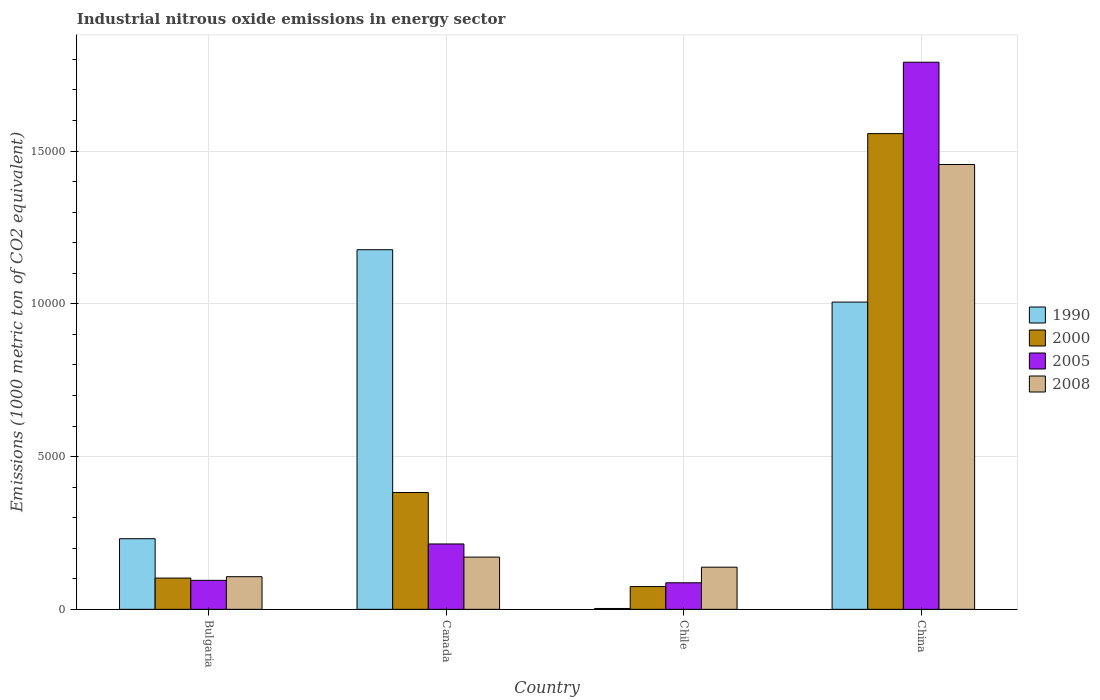Are the number of bars per tick equal to the number of legend labels?
Your answer should be compact. Yes. How many bars are there on the 4th tick from the right?
Offer a terse response. 4. What is the label of the 2nd group of bars from the left?
Provide a short and direct response. Canada. What is the amount of industrial nitrous oxide emitted in 2005 in Canada?
Make the answer very short. 2139.7. Across all countries, what is the maximum amount of industrial nitrous oxide emitted in 2008?
Offer a terse response. 1.46e+04. Across all countries, what is the minimum amount of industrial nitrous oxide emitted in 2008?
Offer a terse response. 1068. What is the total amount of industrial nitrous oxide emitted in 2000 in the graph?
Provide a succinct answer. 2.12e+04. What is the difference between the amount of industrial nitrous oxide emitted in 1990 in Bulgaria and that in Canada?
Your answer should be very brief. -9458.8. What is the difference between the amount of industrial nitrous oxide emitted in 2008 in China and the amount of industrial nitrous oxide emitted in 2000 in Bulgaria?
Provide a short and direct response. 1.35e+04. What is the average amount of industrial nitrous oxide emitted in 2005 per country?
Keep it short and to the point. 5465.88. What is the difference between the amount of industrial nitrous oxide emitted of/in 2008 and amount of industrial nitrous oxide emitted of/in 2005 in Bulgaria?
Ensure brevity in your answer.  119.4. What is the ratio of the amount of industrial nitrous oxide emitted in 2005 in Bulgaria to that in China?
Provide a succinct answer. 0.05. Is the amount of industrial nitrous oxide emitted in 2008 in Bulgaria less than that in China?
Offer a very short reply. Yes. Is the difference between the amount of industrial nitrous oxide emitted in 2008 in Bulgaria and Canada greater than the difference between the amount of industrial nitrous oxide emitted in 2005 in Bulgaria and Canada?
Offer a very short reply. Yes. What is the difference between the highest and the second highest amount of industrial nitrous oxide emitted in 1990?
Ensure brevity in your answer.  -1713.9. What is the difference between the highest and the lowest amount of industrial nitrous oxide emitted in 2000?
Provide a short and direct response. 1.48e+04. In how many countries, is the amount of industrial nitrous oxide emitted in 1990 greater than the average amount of industrial nitrous oxide emitted in 1990 taken over all countries?
Offer a terse response. 2. Is it the case that in every country, the sum of the amount of industrial nitrous oxide emitted in 1990 and amount of industrial nitrous oxide emitted in 2005 is greater than the sum of amount of industrial nitrous oxide emitted in 2000 and amount of industrial nitrous oxide emitted in 2008?
Provide a short and direct response. No. What does the 3rd bar from the left in Bulgaria represents?
Your response must be concise. 2005. What does the 3rd bar from the right in Chile represents?
Keep it short and to the point. 2000. Is it the case that in every country, the sum of the amount of industrial nitrous oxide emitted in 2008 and amount of industrial nitrous oxide emitted in 1990 is greater than the amount of industrial nitrous oxide emitted in 2005?
Ensure brevity in your answer.  Yes. How many bars are there?
Keep it short and to the point. 16. Are all the bars in the graph horizontal?
Ensure brevity in your answer.  No. How many countries are there in the graph?
Your response must be concise. 4. Are the values on the major ticks of Y-axis written in scientific E-notation?
Your answer should be very brief. No. Does the graph contain grids?
Keep it short and to the point. Yes. How many legend labels are there?
Offer a very short reply. 4. How are the legend labels stacked?
Ensure brevity in your answer.  Vertical. What is the title of the graph?
Ensure brevity in your answer.  Industrial nitrous oxide emissions in energy sector. Does "2009" appear as one of the legend labels in the graph?
Your answer should be compact. No. What is the label or title of the Y-axis?
Give a very brief answer. Emissions (1000 metric ton of CO2 equivalent). What is the Emissions (1000 metric ton of CO2 equivalent) in 1990 in Bulgaria?
Offer a very short reply. 2311.2. What is the Emissions (1000 metric ton of CO2 equivalent) in 2000 in Bulgaria?
Your answer should be very brief. 1023. What is the Emissions (1000 metric ton of CO2 equivalent) in 2005 in Bulgaria?
Your answer should be very brief. 948.6. What is the Emissions (1000 metric ton of CO2 equivalent) in 2008 in Bulgaria?
Your answer should be compact. 1068. What is the Emissions (1000 metric ton of CO2 equivalent) in 1990 in Canada?
Your answer should be compact. 1.18e+04. What is the Emissions (1000 metric ton of CO2 equivalent) in 2000 in Canada?
Make the answer very short. 3823.3. What is the Emissions (1000 metric ton of CO2 equivalent) in 2005 in Canada?
Make the answer very short. 2139.7. What is the Emissions (1000 metric ton of CO2 equivalent) in 2008 in Canada?
Keep it short and to the point. 1709.6. What is the Emissions (1000 metric ton of CO2 equivalent) in 1990 in Chile?
Ensure brevity in your answer.  27.9. What is the Emissions (1000 metric ton of CO2 equivalent) of 2000 in Chile?
Ensure brevity in your answer.  744.9. What is the Emissions (1000 metric ton of CO2 equivalent) of 2005 in Chile?
Give a very brief answer. 868.8. What is the Emissions (1000 metric ton of CO2 equivalent) of 2008 in Chile?
Offer a very short reply. 1379.7. What is the Emissions (1000 metric ton of CO2 equivalent) of 1990 in China?
Ensure brevity in your answer.  1.01e+04. What is the Emissions (1000 metric ton of CO2 equivalent) in 2000 in China?
Make the answer very short. 1.56e+04. What is the Emissions (1000 metric ton of CO2 equivalent) in 2005 in China?
Offer a terse response. 1.79e+04. What is the Emissions (1000 metric ton of CO2 equivalent) of 2008 in China?
Your answer should be very brief. 1.46e+04. Across all countries, what is the maximum Emissions (1000 metric ton of CO2 equivalent) in 1990?
Your answer should be compact. 1.18e+04. Across all countries, what is the maximum Emissions (1000 metric ton of CO2 equivalent) in 2000?
Your response must be concise. 1.56e+04. Across all countries, what is the maximum Emissions (1000 metric ton of CO2 equivalent) in 2005?
Provide a succinct answer. 1.79e+04. Across all countries, what is the maximum Emissions (1000 metric ton of CO2 equivalent) in 2008?
Give a very brief answer. 1.46e+04. Across all countries, what is the minimum Emissions (1000 metric ton of CO2 equivalent) of 1990?
Offer a terse response. 27.9. Across all countries, what is the minimum Emissions (1000 metric ton of CO2 equivalent) of 2000?
Your answer should be very brief. 744.9. Across all countries, what is the minimum Emissions (1000 metric ton of CO2 equivalent) in 2005?
Offer a very short reply. 868.8. Across all countries, what is the minimum Emissions (1000 metric ton of CO2 equivalent) of 2008?
Provide a succinct answer. 1068. What is the total Emissions (1000 metric ton of CO2 equivalent) of 1990 in the graph?
Your answer should be very brief. 2.42e+04. What is the total Emissions (1000 metric ton of CO2 equivalent) of 2000 in the graph?
Keep it short and to the point. 2.12e+04. What is the total Emissions (1000 metric ton of CO2 equivalent) of 2005 in the graph?
Keep it short and to the point. 2.19e+04. What is the total Emissions (1000 metric ton of CO2 equivalent) of 2008 in the graph?
Provide a short and direct response. 1.87e+04. What is the difference between the Emissions (1000 metric ton of CO2 equivalent) of 1990 in Bulgaria and that in Canada?
Provide a succinct answer. -9458.8. What is the difference between the Emissions (1000 metric ton of CO2 equivalent) in 2000 in Bulgaria and that in Canada?
Provide a succinct answer. -2800.3. What is the difference between the Emissions (1000 metric ton of CO2 equivalent) in 2005 in Bulgaria and that in Canada?
Provide a succinct answer. -1191.1. What is the difference between the Emissions (1000 metric ton of CO2 equivalent) in 2008 in Bulgaria and that in Canada?
Your response must be concise. -641.6. What is the difference between the Emissions (1000 metric ton of CO2 equivalent) in 1990 in Bulgaria and that in Chile?
Give a very brief answer. 2283.3. What is the difference between the Emissions (1000 metric ton of CO2 equivalent) of 2000 in Bulgaria and that in Chile?
Ensure brevity in your answer.  278.1. What is the difference between the Emissions (1000 metric ton of CO2 equivalent) of 2005 in Bulgaria and that in Chile?
Your response must be concise. 79.8. What is the difference between the Emissions (1000 metric ton of CO2 equivalent) in 2008 in Bulgaria and that in Chile?
Offer a very short reply. -311.7. What is the difference between the Emissions (1000 metric ton of CO2 equivalent) of 1990 in Bulgaria and that in China?
Give a very brief answer. -7744.9. What is the difference between the Emissions (1000 metric ton of CO2 equivalent) in 2000 in Bulgaria and that in China?
Provide a short and direct response. -1.45e+04. What is the difference between the Emissions (1000 metric ton of CO2 equivalent) in 2005 in Bulgaria and that in China?
Keep it short and to the point. -1.70e+04. What is the difference between the Emissions (1000 metric ton of CO2 equivalent) in 2008 in Bulgaria and that in China?
Your response must be concise. -1.35e+04. What is the difference between the Emissions (1000 metric ton of CO2 equivalent) in 1990 in Canada and that in Chile?
Your response must be concise. 1.17e+04. What is the difference between the Emissions (1000 metric ton of CO2 equivalent) of 2000 in Canada and that in Chile?
Offer a terse response. 3078.4. What is the difference between the Emissions (1000 metric ton of CO2 equivalent) of 2005 in Canada and that in Chile?
Offer a terse response. 1270.9. What is the difference between the Emissions (1000 metric ton of CO2 equivalent) of 2008 in Canada and that in Chile?
Your answer should be compact. 329.9. What is the difference between the Emissions (1000 metric ton of CO2 equivalent) in 1990 in Canada and that in China?
Offer a terse response. 1713.9. What is the difference between the Emissions (1000 metric ton of CO2 equivalent) in 2000 in Canada and that in China?
Your answer should be very brief. -1.17e+04. What is the difference between the Emissions (1000 metric ton of CO2 equivalent) in 2005 in Canada and that in China?
Keep it short and to the point. -1.58e+04. What is the difference between the Emissions (1000 metric ton of CO2 equivalent) in 2008 in Canada and that in China?
Your response must be concise. -1.28e+04. What is the difference between the Emissions (1000 metric ton of CO2 equivalent) in 1990 in Chile and that in China?
Offer a very short reply. -1.00e+04. What is the difference between the Emissions (1000 metric ton of CO2 equivalent) of 2000 in Chile and that in China?
Your answer should be compact. -1.48e+04. What is the difference between the Emissions (1000 metric ton of CO2 equivalent) of 2005 in Chile and that in China?
Give a very brief answer. -1.70e+04. What is the difference between the Emissions (1000 metric ton of CO2 equivalent) in 2008 in Chile and that in China?
Give a very brief answer. -1.32e+04. What is the difference between the Emissions (1000 metric ton of CO2 equivalent) in 1990 in Bulgaria and the Emissions (1000 metric ton of CO2 equivalent) in 2000 in Canada?
Offer a terse response. -1512.1. What is the difference between the Emissions (1000 metric ton of CO2 equivalent) in 1990 in Bulgaria and the Emissions (1000 metric ton of CO2 equivalent) in 2005 in Canada?
Provide a succinct answer. 171.5. What is the difference between the Emissions (1000 metric ton of CO2 equivalent) in 1990 in Bulgaria and the Emissions (1000 metric ton of CO2 equivalent) in 2008 in Canada?
Offer a very short reply. 601.6. What is the difference between the Emissions (1000 metric ton of CO2 equivalent) of 2000 in Bulgaria and the Emissions (1000 metric ton of CO2 equivalent) of 2005 in Canada?
Give a very brief answer. -1116.7. What is the difference between the Emissions (1000 metric ton of CO2 equivalent) in 2000 in Bulgaria and the Emissions (1000 metric ton of CO2 equivalent) in 2008 in Canada?
Give a very brief answer. -686.6. What is the difference between the Emissions (1000 metric ton of CO2 equivalent) of 2005 in Bulgaria and the Emissions (1000 metric ton of CO2 equivalent) of 2008 in Canada?
Provide a short and direct response. -761. What is the difference between the Emissions (1000 metric ton of CO2 equivalent) in 1990 in Bulgaria and the Emissions (1000 metric ton of CO2 equivalent) in 2000 in Chile?
Keep it short and to the point. 1566.3. What is the difference between the Emissions (1000 metric ton of CO2 equivalent) of 1990 in Bulgaria and the Emissions (1000 metric ton of CO2 equivalent) of 2005 in Chile?
Give a very brief answer. 1442.4. What is the difference between the Emissions (1000 metric ton of CO2 equivalent) in 1990 in Bulgaria and the Emissions (1000 metric ton of CO2 equivalent) in 2008 in Chile?
Keep it short and to the point. 931.5. What is the difference between the Emissions (1000 metric ton of CO2 equivalent) of 2000 in Bulgaria and the Emissions (1000 metric ton of CO2 equivalent) of 2005 in Chile?
Give a very brief answer. 154.2. What is the difference between the Emissions (1000 metric ton of CO2 equivalent) in 2000 in Bulgaria and the Emissions (1000 metric ton of CO2 equivalent) in 2008 in Chile?
Your answer should be compact. -356.7. What is the difference between the Emissions (1000 metric ton of CO2 equivalent) in 2005 in Bulgaria and the Emissions (1000 metric ton of CO2 equivalent) in 2008 in Chile?
Your answer should be very brief. -431.1. What is the difference between the Emissions (1000 metric ton of CO2 equivalent) in 1990 in Bulgaria and the Emissions (1000 metric ton of CO2 equivalent) in 2000 in China?
Offer a terse response. -1.33e+04. What is the difference between the Emissions (1000 metric ton of CO2 equivalent) in 1990 in Bulgaria and the Emissions (1000 metric ton of CO2 equivalent) in 2005 in China?
Offer a very short reply. -1.56e+04. What is the difference between the Emissions (1000 metric ton of CO2 equivalent) in 1990 in Bulgaria and the Emissions (1000 metric ton of CO2 equivalent) in 2008 in China?
Keep it short and to the point. -1.22e+04. What is the difference between the Emissions (1000 metric ton of CO2 equivalent) in 2000 in Bulgaria and the Emissions (1000 metric ton of CO2 equivalent) in 2005 in China?
Offer a very short reply. -1.69e+04. What is the difference between the Emissions (1000 metric ton of CO2 equivalent) of 2000 in Bulgaria and the Emissions (1000 metric ton of CO2 equivalent) of 2008 in China?
Offer a terse response. -1.35e+04. What is the difference between the Emissions (1000 metric ton of CO2 equivalent) of 2005 in Bulgaria and the Emissions (1000 metric ton of CO2 equivalent) of 2008 in China?
Your answer should be compact. -1.36e+04. What is the difference between the Emissions (1000 metric ton of CO2 equivalent) in 1990 in Canada and the Emissions (1000 metric ton of CO2 equivalent) in 2000 in Chile?
Offer a very short reply. 1.10e+04. What is the difference between the Emissions (1000 metric ton of CO2 equivalent) of 1990 in Canada and the Emissions (1000 metric ton of CO2 equivalent) of 2005 in Chile?
Offer a very short reply. 1.09e+04. What is the difference between the Emissions (1000 metric ton of CO2 equivalent) in 1990 in Canada and the Emissions (1000 metric ton of CO2 equivalent) in 2008 in Chile?
Give a very brief answer. 1.04e+04. What is the difference between the Emissions (1000 metric ton of CO2 equivalent) in 2000 in Canada and the Emissions (1000 metric ton of CO2 equivalent) in 2005 in Chile?
Your answer should be compact. 2954.5. What is the difference between the Emissions (1000 metric ton of CO2 equivalent) of 2000 in Canada and the Emissions (1000 metric ton of CO2 equivalent) of 2008 in Chile?
Provide a succinct answer. 2443.6. What is the difference between the Emissions (1000 metric ton of CO2 equivalent) in 2005 in Canada and the Emissions (1000 metric ton of CO2 equivalent) in 2008 in Chile?
Make the answer very short. 760. What is the difference between the Emissions (1000 metric ton of CO2 equivalent) in 1990 in Canada and the Emissions (1000 metric ton of CO2 equivalent) in 2000 in China?
Your answer should be very brief. -3799.7. What is the difference between the Emissions (1000 metric ton of CO2 equivalent) of 1990 in Canada and the Emissions (1000 metric ton of CO2 equivalent) of 2005 in China?
Give a very brief answer. -6136.4. What is the difference between the Emissions (1000 metric ton of CO2 equivalent) in 1990 in Canada and the Emissions (1000 metric ton of CO2 equivalent) in 2008 in China?
Your answer should be compact. -2788.9. What is the difference between the Emissions (1000 metric ton of CO2 equivalent) of 2000 in Canada and the Emissions (1000 metric ton of CO2 equivalent) of 2005 in China?
Provide a succinct answer. -1.41e+04. What is the difference between the Emissions (1000 metric ton of CO2 equivalent) of 2000 in Canada and the Emissions (1000 metric ton of CO2 equivalent) of 2008 in China?
Keep it short and to the point. -1.07e+04. What is the difference between the Emissions (1000 metric ton of CO2 equivalent) of 2005 in Canada and the Emissions (1000 metric ton of CO2 equivalent) of 2008 in China?
Provide a short and direct response. -1.24e+04. What is the difference between the Emissions (1000 metric ton of CO2 equivalent) in 1990 in Chile and the Emissions (1000 metric ton of CO2 equivalent) in 2000 in China?
Offer a terse response. -1.55e+04. What is the difference between the Emissions (1000 metric ton of CO2 equivalent) in 1990 in Chile and the Emissions (1000 metric ton of CO2 equivalent) in 2005 in China?
Provide a short and direct response. -1.79e+04. What is the difference between the Emissions (1000 metric ton of CO2 equivalent) of 1990 in Chile and the Emissions (1000 metric ton of CO2 equivalent) of 2008 in China?
Offer a terse response. -1.45e+04. What is the difference between the Emissions (1000 metric ton of CO2 equivalent) of 2000 in Chile and the Emissions (1000 metric ton of CO2 equivalent) of 2005 in China?
Ensure brevity in your answer.  -1.72e+04. What is the difference between the Emissions (1000 metric ton of CO2 equivalent) in 2000 in Chile and the Emissions (1000 metric ton of CO2 equivalent) in 2008 in China?
Your answer should be compact. -1.38e+04. What is the difference between the Emissions (1000 metric ton of CO2 equivalent) in 2005 in Chile and the Emissions (1000 metric ton of CO2 equivalent) in 2008 in China?
Your answer should be compact. -1.37e+04. What is the average Emissions (1000 metric ton of CO2 equivalent) of 1990 per country?
Your answer should be compact. 6041.3. What is the average Emissions (1000 metric ton of CO2 equivalent) in 2000 per country?
Your answer should be compact. 5290.23. What is the average Emissions (1000 metric ton of CO2 equivalent) in 2005 per country?
Offer a terse response. 5465.88. What is the average Emissions (1000 metric ton of CO2 equivalent) of 2008 per country?
Give a very brief answer. 4679.05. What is the difference between the Emissions (1000 metric ton of CO2 equivalent) of 1990 and Emissions (1000 metric ton of CO2 equivalent) of 2000 in Bulgaria?
Offer a very short reply. 1288.2. What is the difference between the Emissions (1000 metric ton of CO2 equivalent) of 1990 and Emissions (1000 metric ton of CO2 equivalent) of 2005 in Bulgaria?
Ensure brevity in your answer.  1362.6. What is the difference between the Emissions (1000 metric ton of CO2 equivalent) of 1990 and Emissions (1000 metric ton of CO2 equivalent) of 2008 in Bulgaria?
Provide a short and direct response. 1243.2. What is the difference between the Emissions (1000 metric ton of CO2 equivalent) of 2000 and Emissions (1000 metric ton of CO2 equivalent) of 2005 in Bulgaria?
Keep it short and to the point. 74.4. What is the difference between the Emissions (1000 metric ton of CO2 equivalent) in 2000 and Emissions (1000 metric ton of CO2 equivalent) in 2008 in Bulgaria?
Keep it short and to the point. -45. What is the difference between the Emissions (1000 metric ton of CO2 equivalent) in 2005 and Emissions (1000 metric ton of CO2 equivalent) in 2008 in Bulgaria?
Provide a short and direct response. -119.4. What is the difference between the Emissions (1000 metric ton of CO2 equivalent) in 1990 and Emissions (1000 metric ton of CO2 equivalent) in 2000 in Canada?
Make the answer very short. 7946.7. What is the difference between the Emissions (1000 metric ton of CO2 equivalent) in 1990 and Emissions (1000 metric ton of CO2 equivalent) in 2005 in Canada?
Your response must be concise. 9630.3. What is the difference between the Emissions (1000 metric ton of CO2 equivalent) of 1990 and Emissions (1000 metric ton of CO2 equivalent) of 2008 in Canada?
Ensure brevity in your answer.  1.01e+04. What is the difference between the Emissions (1000 metric ton of CO2 equivalent) in 2000 and Emissions (1000 metric ton of CO2 equivalent) in 2005 in Canada?
Give a very brief answer. 1683.6. What is the difference between the Emissions (1000 metric ton of CO2 equivalent) in 2000 and Emissions (1000 metric ton of CO2 equivalent) in 2008 in Canada?
Make the answer very short. 2113.7. What is the difference between the Emissions (1000 metric ton of CO2 equivalent) of 2005 and Emissions (1000 metric ton of CO2 equivalent) of 2008 in Canada?
Offer a very short reply. 430.1. What is the difference between the Emissions (1000 metric ton of CO2 equivalent) in 1990 and Emissions (1000 metric ton of CO2 equivalent) in 2000 in Chile?
Your answer should be very brief. -717. What is the difference between the Emissions (1000 metric ton of CO2 equivalent) of 1990 and Emissions (1000 metric ton of CO2 equivalent) of 2005 in Chile?
Offer a terse response. -840.9. What is the difference between the Emissions (1000 metric ton of CO2 equivalent) of 1990 and Emissions (1000 metric ton of CO2 equivalent) of 2008 in Chile?
Make the answer very short. -1351.8. What is the difference between the Emissions (1000 metric ton of CO2 equivalent) of 2000 and Emissions (1000 metric ton of CO2 equivalent) of 2005 in Chile?
Provide a succinct answer. -123.9. What is the difference between the Emissions (1000 metric ton of CO2 equivalent) in 2000 and Emissions (1000 metric ton of CO2 equivalent) in 2008 in Chile?
Offer a terse response. -634.8. What is the difference between the Emissions (1000 metric ton of CO2 equivalent) in 2005 and Emissions (1000 metric ton of CO2 equivalent) in 2008 in Chile?
Keep it short and to the point. -510.9. What is the difference between the Emissions (1000 metric ton of CO2 equivalent) of 1990 and Emissions (1000 metric ton of CO2 equivalent) of 2000 in China?
Offer a terse response. -5513.6. What is the difference between the Emissions (1000 metric ton of CO2 equivalent) of 1990 and Emissions (1000 metric ton of CO2 equivalent) of 2005 in China?
Your answer should be compact. -7850.3. What is the difference between the Emissions (1000 metric ton of CO2 equivalent) in 1990 and Emissions (1000 metric ton of CO2 equivalent) in 2008 in China?
Provide a short and direct response. -4502.8. What is the difference between the Emissions (1000 metric ton of CO2 equivalent) in 2000 and Emissions (1000 metric ton of CO2 equivalent) in 2005 in China?
Your response must be concise. -2336.7. What is the difference between the Emissions (1000 metric ton of CO2 equivalent) of 2000 and Emissions (1000 metric ton of CO2 equivalent) of 2008 in China?
Give a very brief answer. 1010.8. What is the difference between the Emissions (1000 metric ton of CO2 equivalent) of 2005 and Emissions (1000 metric ton of CO2 equivalent) of 2008 in China?
Make the answer very short. 3347.5. What is the ratio of the Emissions (1000 metric ton of CO2 equivalent) of 1990 in Bulgaria to that in Canada?
Ensure brevity in your answer.  0.2. What is the ratio of the Emissions (1000 metric ton of CO2 equivalent) of 2000 in Bulgaria to that in Canada?
Your answer should be compact. 0.27. What is the ratio of the Emissions (1000 metric ton of CO2 equivalent) in 2005 in Bulgaria to that in Canada?
Provide a short and direct response. 0.44. What is the ratio of the Emissions (1000 metric ton of CO2 equivalent) of 2008 in Bulgaria to that in Canada?
Keep it short and to the point. 0.62. What is the ratio of the Emissions (1000 metric ton of CO2 equivalent) of 1990 in Bulgaria to that in Chile?
Give a very brief answer. 82.84. What is the ratio of the Emissions (1000 metric ton of CO2 equivalent) of 2000 in Bulgaria to that in Chile?
Keep it short and to the point. 1.37. What is the ratio of the Emissions (1000 metric ton of CO2 equivalent) in 2005 in Bulgaria to that in Chile?
Provide a short and direct response. 1.09. What is the ratio of the Emissions (1000 metric ton of CO2 equivalent) in 2008 in Bulgaria to that in Chile?
Your answer should be compact. 0.77. What is the ratio of the Emissions (1000 metric ton of CO2 equivalent) of 1990 in Bulgaria to that in China?
Ensure brevity in your answer.  0.23. What is the ratio of the Emissions (1000 metric ton of CO2 equivalent) in 2000 in Bulgaria to that in China?
Provide a succinct answer. 0.07. What is the ratio of the Emissions (1000 metric ton of CO2 equivalent) of 2005 in Bulgaria to that in China?
Provide a succinct answer. 0.05. What is the ratio of the Emissions (1000 metric ton of CO2 equivalent) in 2008 in Bulgaria to that in China?
Your answer should be compact. 0.07. What is the ratio of the Emissions (1000 metric ton of CO2 equivalent) of 1990 in Canada to that in Chile?
Give a very brief answer. 421.86. What is the ratio of the Emissions (1000 metric ton of CO2 equivalent) in 2000 in Canada to that in Chile?
Provide a succinct answer. 5.13. What is the ratio of the Emissions (1000 metric ton of CO2 equivalent) in 2005 in Canada to that in Chile?
Your answer should be very brief. 2.46. What is the ratio of the Emissions (1000 metric ton of CO2 equivalent) of 2008 in Canada to that in Chile?
Your answer should be very brief. 1.24. What is the ratio of the Emissions (1000 metric ton of CO2 equivalent) in 1990 in Canada to that in China?
Give a very brief answer. 1.17. What is the ratio of the Emissions (1000 metric ton of CO2 equivalent) of 2000 in Canada to that in China?
Offer a very short reply. 0.25. What is the ratio of the Emissions (1000 metric ton of CO2 equivalent) of 2005 in Canada to that in China?
Make the answer very short. 0.12. What is the ratio of the Emissions (1000 metric ton of CO2 equivalent) in 2008 in Canada to that in China?
Provide a succinct answer. 0.12. What is the ratio of the Emissions (1000 metric ton of CO2 equivalent) of 1990 in Chile to that in China?
Offer a terse response. 0. What is the ratio of the Emissions (1000 metric ton of CO2 equivalent) in 2000 in Chile to that in China?
Make the answer very short. 0.05. What is the ratio of the Emissions (1000 metric ton of CO2 equivalent) in 2005 in Chile to that in China?
Offer a very short reply. 0.05. What is the ratio of the Emissions (1000 metric ton of CO2 equivalent) of 2008 in Chile to that in China?
Keep it short and to the point. 0.09. What is the difference between the highest and the second highest Emissions (1000 metric ton of CO2 equivalent) in 1990?
Provide a succinct answer. 1713.9. What is the difference between the highest and the second highest Emissions (1000 metric ton of CO2 equivalent) in 2000?
Ensure brevity in your answer.  1.17e+04. What is the difference between the highest and the second highest Emissions (1000 metric ton of CO2 equivalent) of 2005?
Provide a short and direct response. 1.58e+04. What is the difference between the highest and the second highest Emissions (1000 metric ton of CO2 equivalent) in 2008?
Offer a very short reply. 1.28e+04. What is the difference between the highest and the lowest Emissions (1000 metric ton of CO2 equivalent) of 1990?
Provide a succinct answer. 1.17e+04. What is the difference between the highest and the lowest Emissions (1000 metric ton of CO2 equivalent) in 2000?
Give a very brief answer. 1.48e+04. What is the difference between the highest and the lowest Emissions (1000 metric ton of CO2 equivalent) of 2005?
Your answer should be very brief. 1.70e+04. What is the difference between the highest and the lowest Emissions (1000 metric ton of CO2 equivalent) in 2008?
Keep it short and to the point. 1.35e+04. 